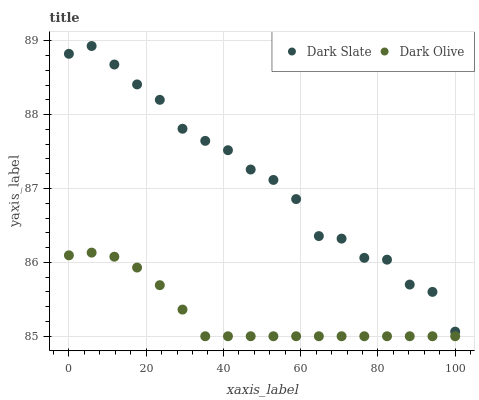Does Dark Olive have the minimum area under the curve?
Answer yes or no. Yes. Does Dark Slate have the maximum area under the curve?
Answer yes or no. Yes. Does Dark Olive have the maximum area under the curve?
Answer yes or no. No. Is Dark Olive the smoothest?
Answer yes or no. Yes. Is Dark Slate the roughest?
Answer yes or no. Yes. Is Dark Olive the roughest?
Answer yes or no. No. Does Dark Olive have the lowest value?
Answer yes or no. Yes. Does Dark Slate have the highest value?
Answer yes or no. Yes. Does Dark Olive have the highest value?
Answer yes or no. No. Is Dark Olive less than Dark Slate?
Answer yes or no. Yes. Is Dark Slate greater than Dark Olive?
Answer yes or no. Yes. Does Dark Olive intersect Dark Slate?
Answer yes or no. No. 